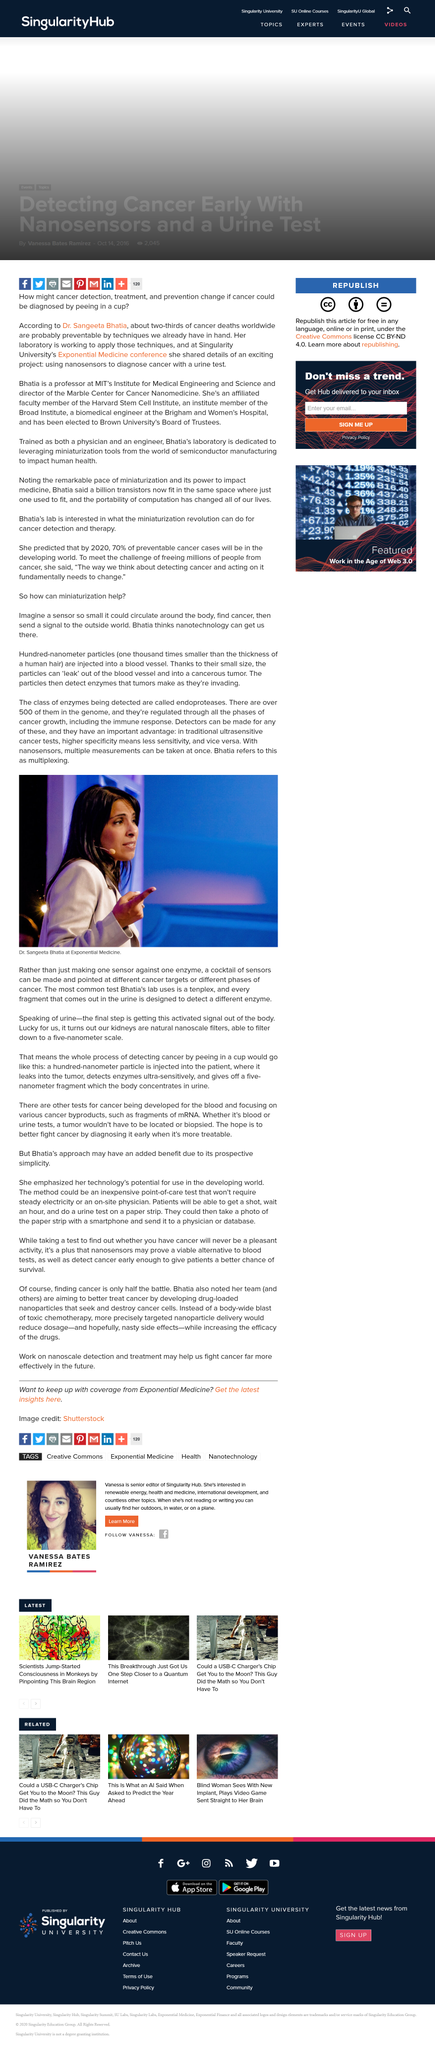Draw attention to some important aspects in this diagram. The particles are one-thousand times smaller than the thickness of a human hair, making them incredibly small in relation to a human hair. The photograph depicts Dr. Sangeeta Bhatia. Endoproteases are the class of enzymes that are detected by the particles. 